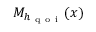Convert formula to latex. <formula><loc_0><loc_0><loc_500><loc_500>M _ { h _ { q o i } } ( x )</formula> 